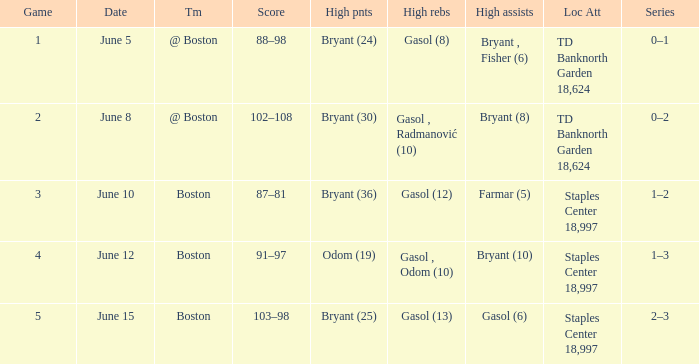Name the location on june 10 Staples Center 18,997. 